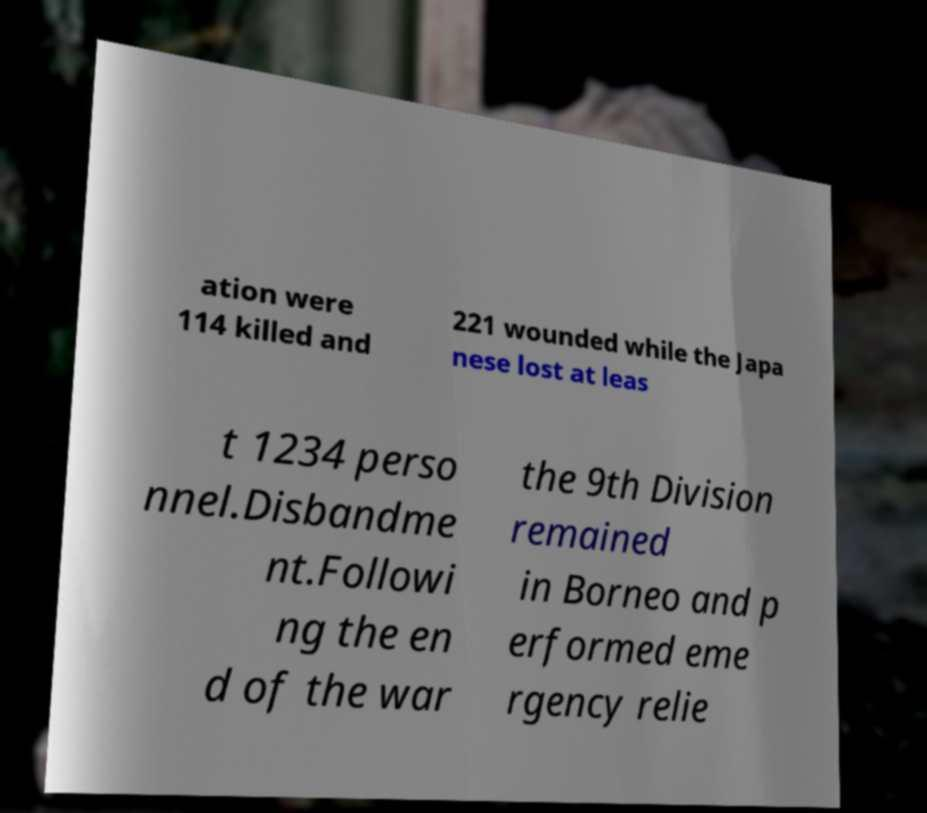Can you read and provide the text displayed in the image?This photo seems to have some interesting text. Can you extract and type it out for me? ation were 114 killed and 221 wounded while the Japa nese lost at leas t 1234 perso nnel.Disbandme nt.Followi ng the en d of the war the 9th Division remained in Borneo and p erformed eme rgency relie 